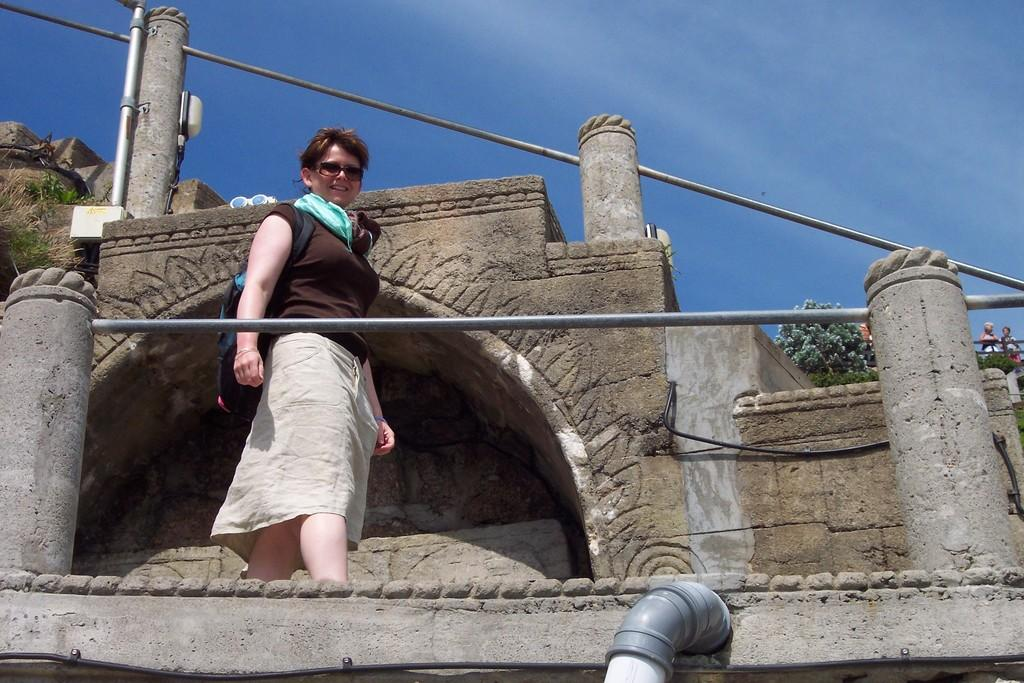What is the primary subject of the image? There is a woman standing in the image. Where is the woman located in the image? The woman is on the floor. What is the woman's facial expression in the image? The woman is smiling. What can be seen in the background of the image? There is sky, clouds, a monument, trees, and a pipeline visible in the background of the image. What type of bear can be seen observing the woman in the image? There is no bear present in the image; the woman is standing alone. How does the woman control the pipeline in the background of the image? The woman does not control the pipeline in the image; it is a separate element in the background. 